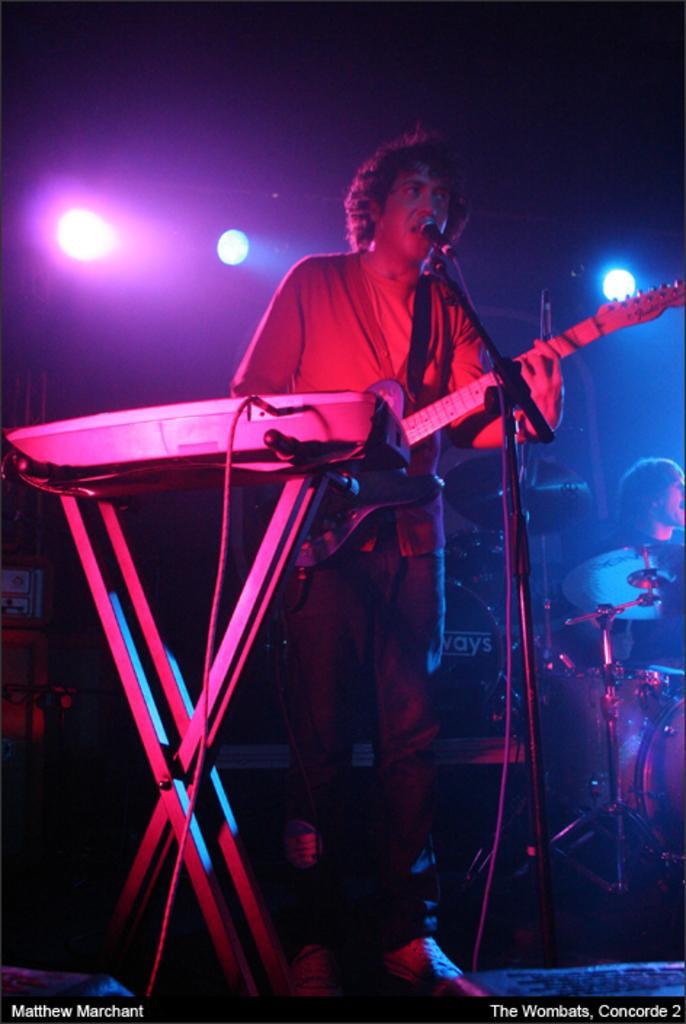In one or two sentences, can you explain what this image depicts? In this image, we can see a person is holding a guitar and standing in-front of a microphone. Here we can see stand, wire, musical player. Background we can see few instruments, person, few objects. Here we can see dark view and lights. At the bottom of the image, we can see some text. 